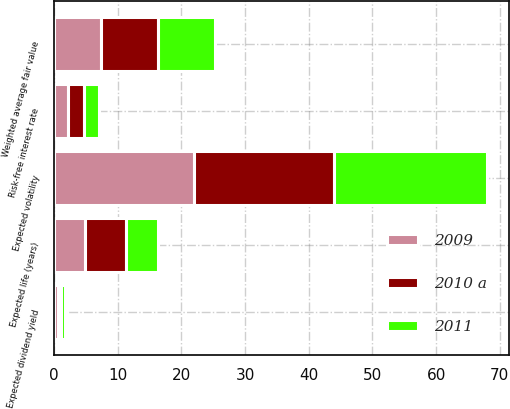<chart> <loc_0><loc_0><loc_500><loc_500><stacked_bar_chart><ecel><fcel>Weighted average fair value<fcel>Expected dividend yield<fcel>Risk-free interest rate<fcel>Expected volatility<fcel>Expected life (years)<nl><fcel>2011<fcel>8.86<fcel>0.55<fcel>2.35<fcel>24<fcel>5.07<nl><fcel>2010 a<fcel>9.06<fcel>0.58<fcel>2.55<fcel>22<fcel>6.42<nl><fcel>2009<fcel>7.31<fcel>0.6<fcel>2.14<fcel>22<fcel>4.84<nl></chart> 